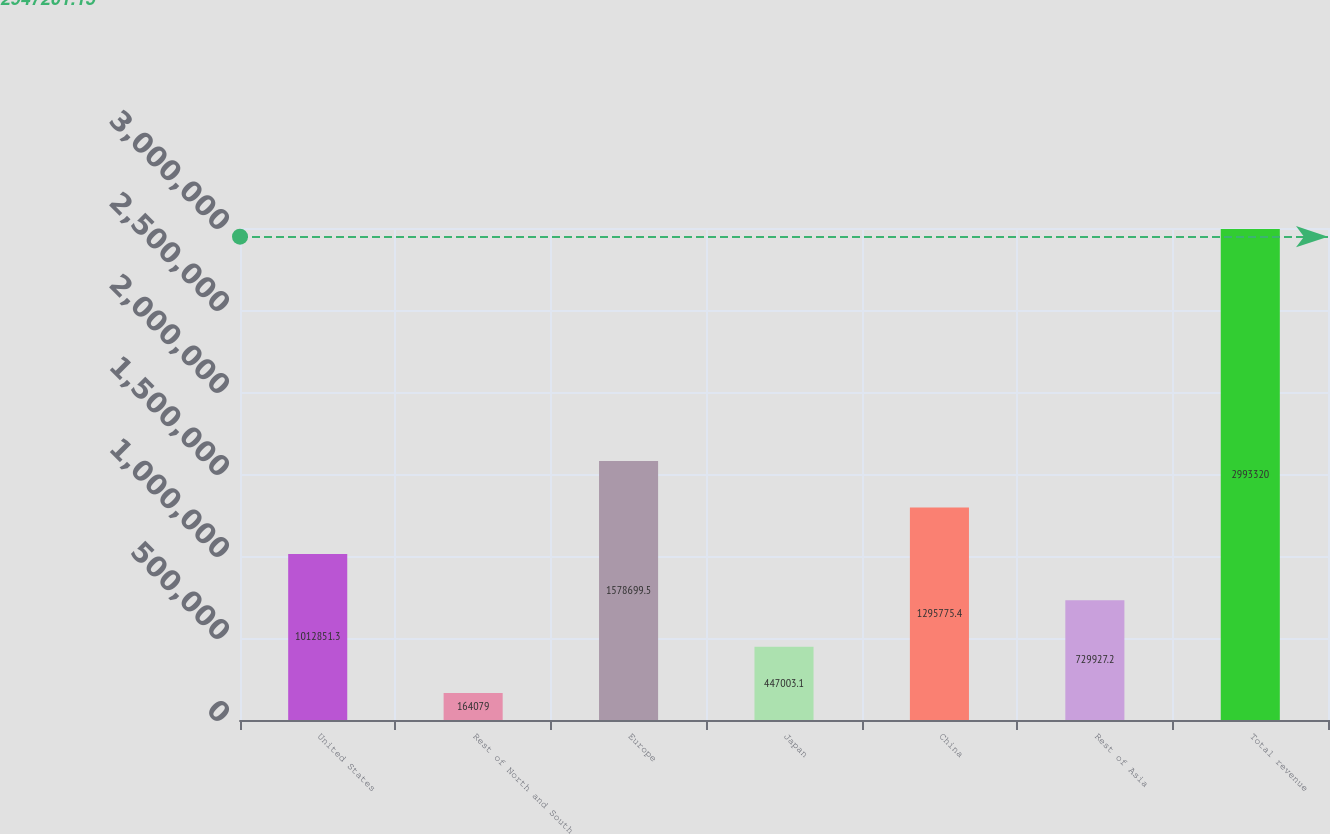Convert chart. <chart><loc_0><loc_0><loc_500><loc_500><bar_chart><fcel>United States<fcel>Rest of North and South<fcel>Europe<fcel>Japan<fcel>China<fcel>Rest of Asia<fcel>Total revenue<nl><fcel>1.01285e+06<fcel>164079<fcel>1.5787e+06<fcel>447003<fcel>1.29578e+06<fcel>729927<fcel>2.99332e+06<nl></chart> 